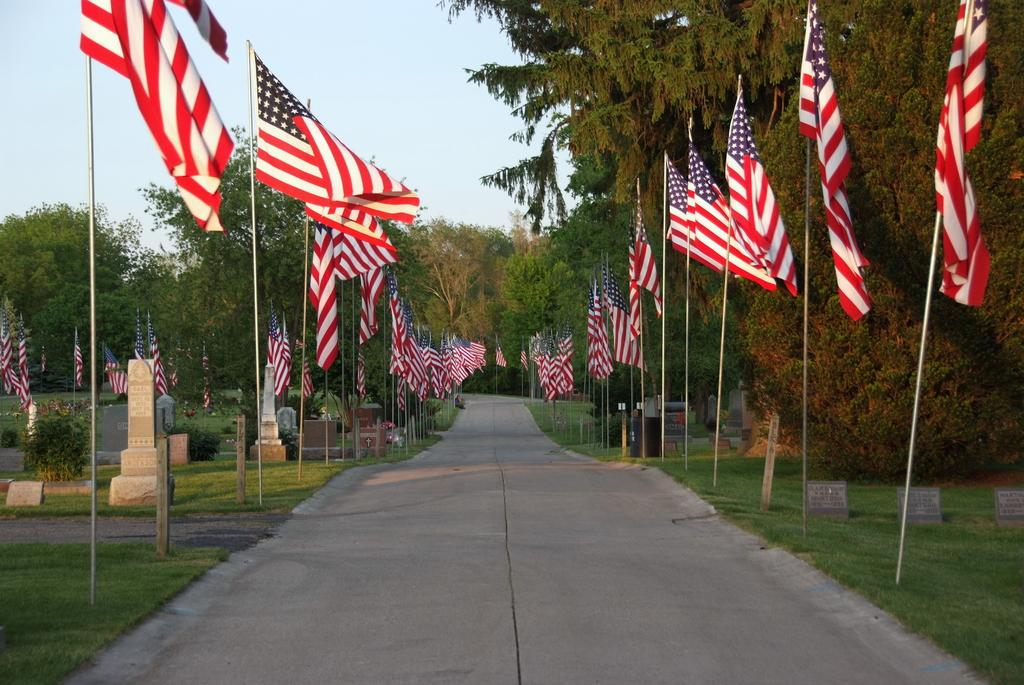What is the main feature in the middle of the image? There is a path in the middle of the image. What can be seen on both sides of the path? There are many flags on both sides of the path. What architectural elements are present in the image? There are pillars in the image. What type of natural scenery is visible in the background? There are trees in the background of the image. How does the throat of the person in the image look like? There is no person present in the image, so it is not possible to determine the appearance of their throat. 